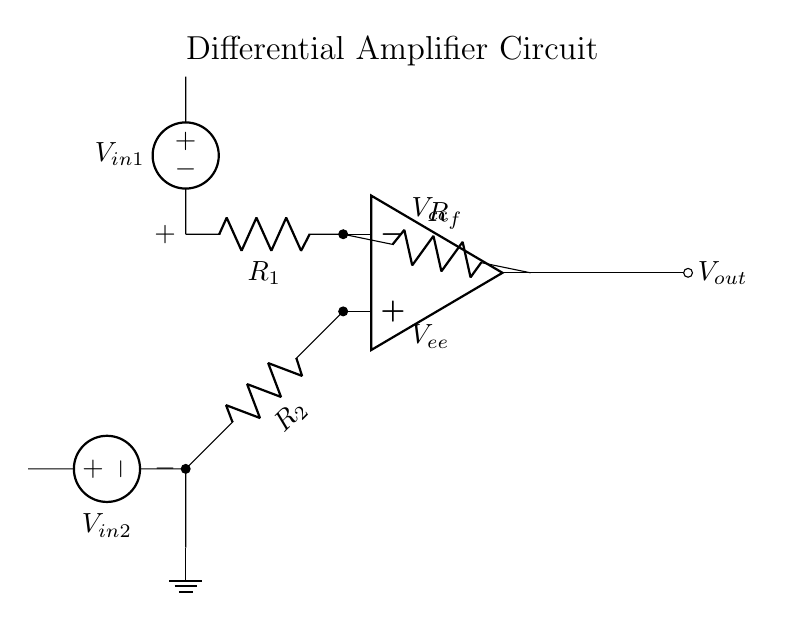What is the role of the op-amp in this circuit? The op-amp serves as the main amplifying component, taking the differential input voltage (the difference between the two input voltages) and producing a corresponding output voltage that is proportional to this difference.
Answer: Amplifier What are the values of the resistors labeled in the circuit? The resistors in the circuit are labeled as R1, R2, and Rf, which represent the input and feedback resistors of the differential amplifier. The specific numerical values are not provided in the circuit diagram, but they follow standard conventions for differential amplifiers.
Answer: R1, R2, Rf Which input voltage source is connected to the non-inverting terminal? The voltage source V_in1 is connected to the non-inverting terminal of the op-amp, which is the positive input.
Answer: V_in1 What is the expected output if V_in1 is greater than V_in2? If V_in1 is greater than V_in2, the output voltage V_out will be positive, indicating that the non-inverting input signal is larger than the inverting input. The output will reflect this difference, amplified by the gain determined by the resistor values.
Answer: Positive How does the feedback resistor affect the circuit? The feedback resistor Rf stabilizes the gain of the op-amp and determines the relationship between the output voltage and the input voltage difference across the op-amp. It allows negative feedback, which improves linearity and bandwidth in the signal amplification.
Answer: Stabilizes gain What is the function of the ground connection in this circuit? The ground connection provides a reference point for the circuit, ensuring a stable voltage level for the negative terminal (inverting input) and helping to complete the circuit path. It establishes a common return path for the current.
Answer: Reference point 